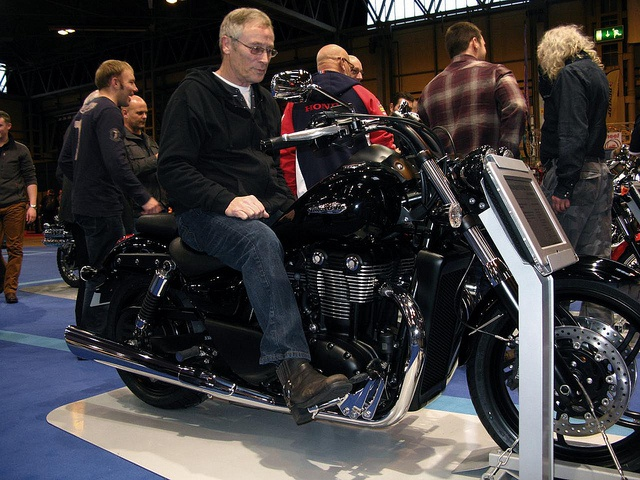Describe the objects in this image and their specific colors. I can see motorcycle in black, gray, lightgray, and darkgray tones, people in black and gray tones, people in black, gray, and tan tones, people in black, maroon, and brown tones, and people in black, maroon, gray, and brown tones in this image. 